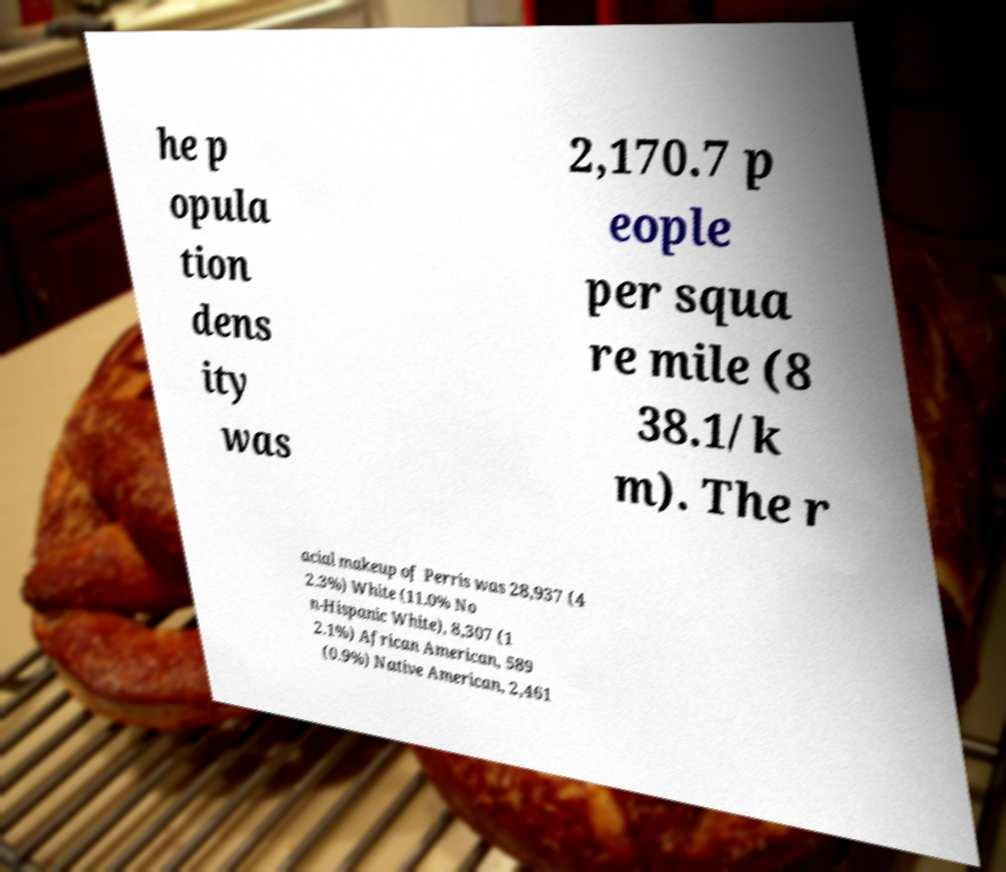Could you extract and type out the text from this image? he p opula tion dens ity was 2,170.7 p eople per squa re mile (8 38.1/k m). The r acial makeup of Perris was 28,937 (4 2.3%) White (11.0% No n-Hispanic White), 8,307 (1 2.1%) African American, 589 (0.9%) Native American, 2,461 